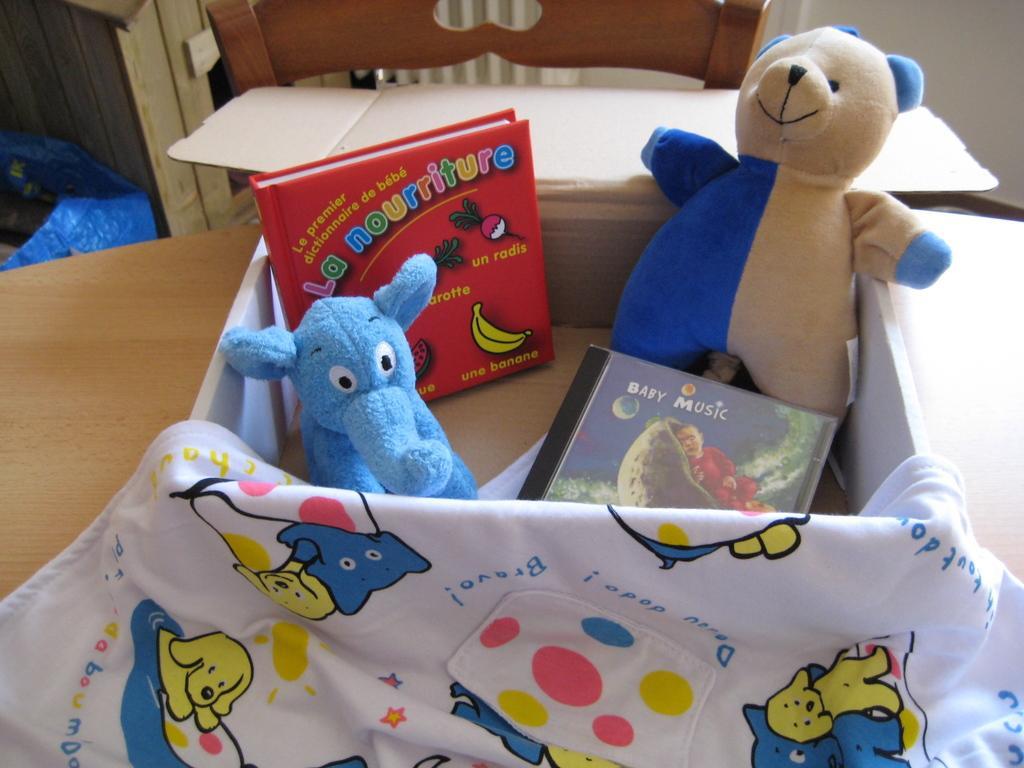Could you give a brief overview of what you see in this image? In the foreground of the picture there are desk, towel and box, in the box there are books and toys. At the top chair, cover, wall and a wooden object. 